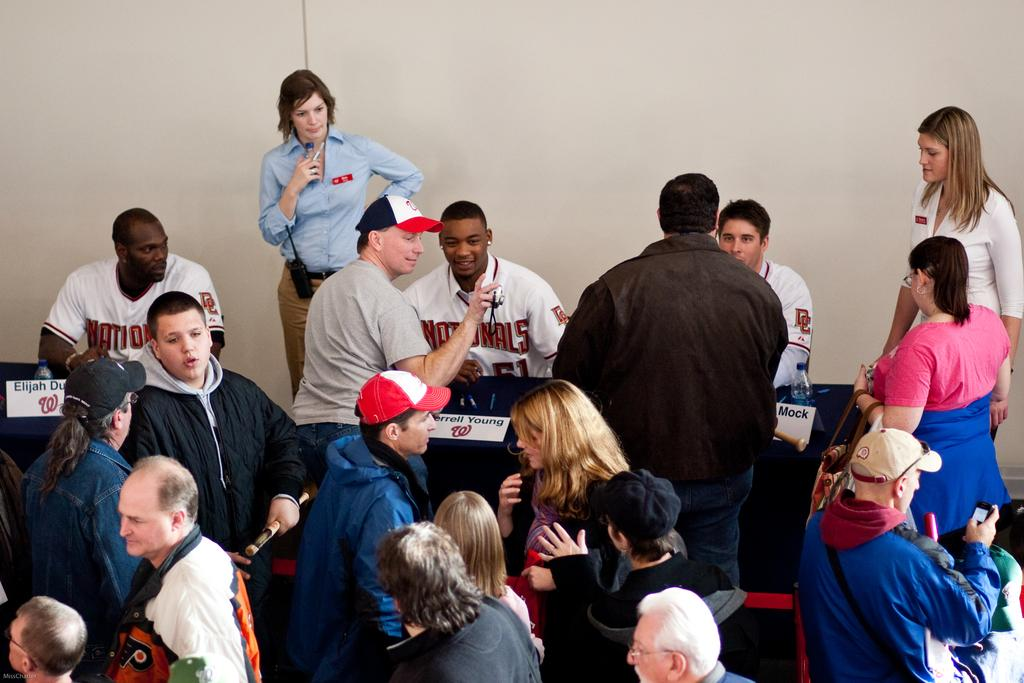How many people are in the image? There are people in the image, but the exact number is not specified. What are the people doing in the image? Most of the people are standing, and they are engaged in a discussion. Can you describe the body language of the people in the image? Since most of the people are standing, it suggests they are actively participating in the discussion. What type of flowers can be seen in the image? There is no mention of flowers in the image, so it is not possible to answer that question. 